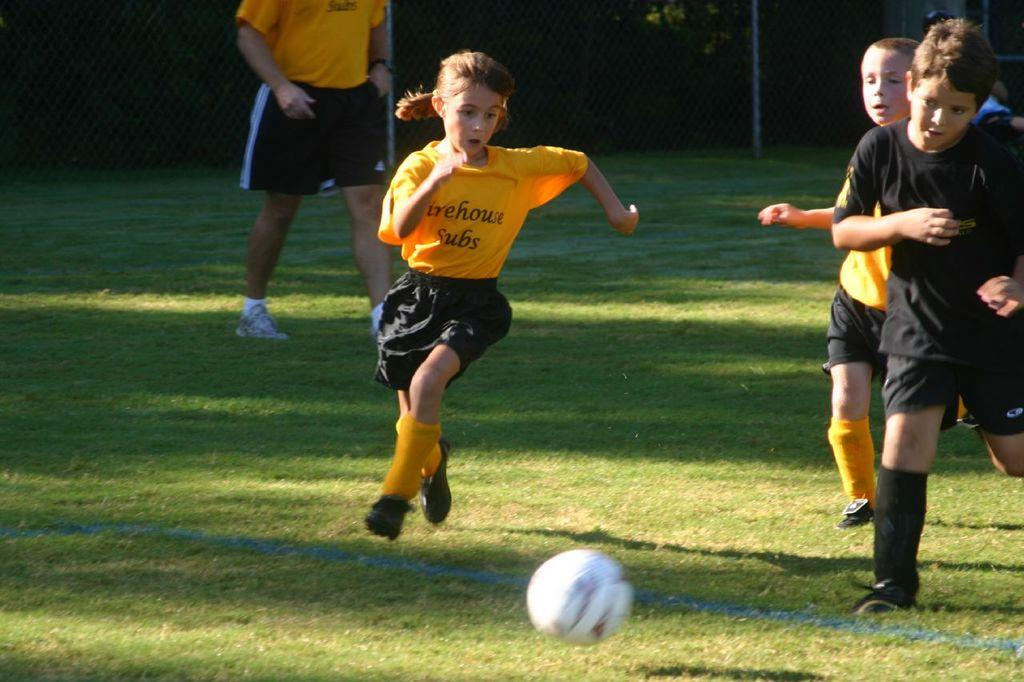What activity are the people in the image engaged in? The people in the image are playing a game. Where is the game being played? The game is being played on the grass. What object is in front of the people playing the game? There is a ball in front of the people playing the game. What can be seen in the background of the image? There is a fence and metal rods in the background of the image. What type of fact can be seen in the image? There is no fact present in the image; it is a photograph of people playing a game on the grass. What kind of relation is depicted between the people and the ball in the image? The image does not show a direct relation between the people and the ball; it only shows the ball in front of them. 